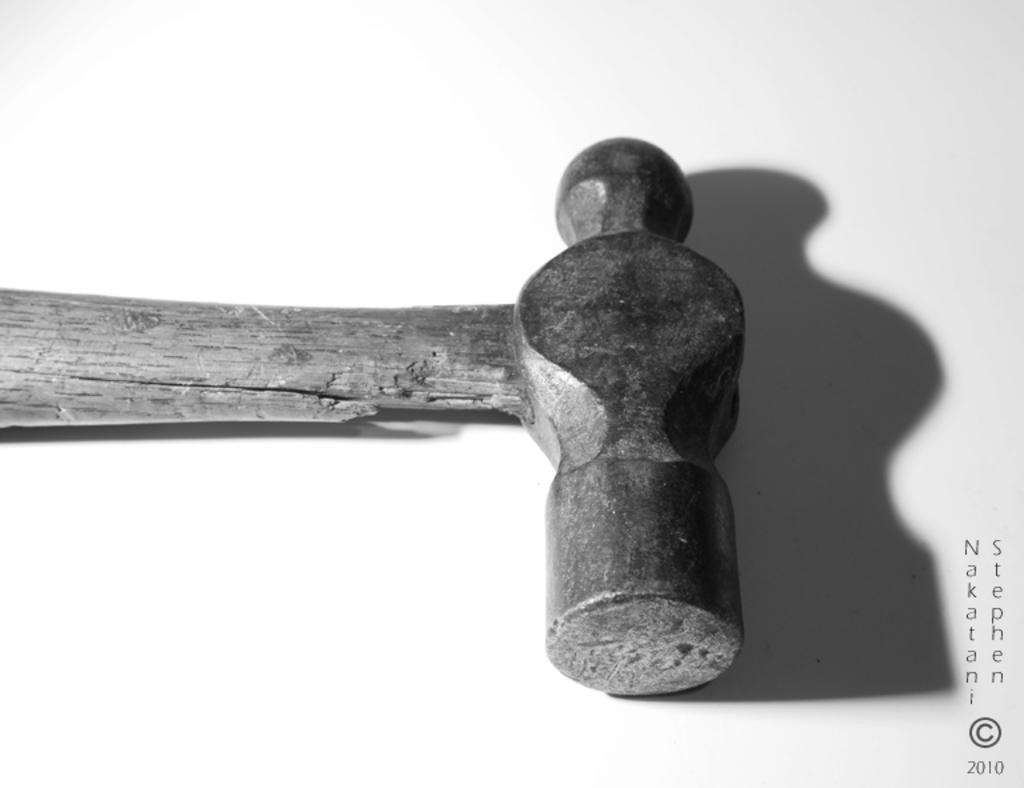In one or two sentences, can you explain what this image depicts? In this image we can see one hammer, some text and numbers on the bottom right side of the image. There is the white background. 